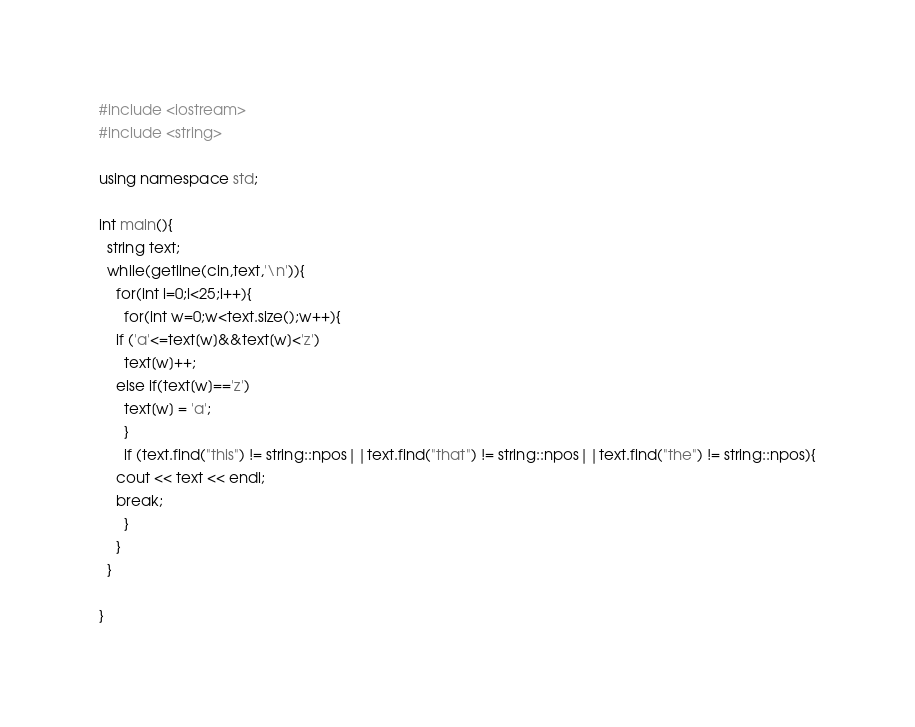Convert code to text. <code><loc_0><loc_0><loc_500><loc_500><_C++_>#include <iostream>
#include <string>

using namespace std;

int main(){
  string text;
  while(getline(cin,text,'\n')){
    for(int i=0;i<25;i++){
      for(int w=0;w<text.size();w++){
	if ('a'<=text[w]&&text[w]<'z')
	  text[w]++;
	else if(text[w]=='z')
	  text[w] = 'a';
      }
      if (text.find("this") != string::npos||text.find("that") != string::npos||text.find("the") != string::npos){
	cout << text << endl;
	break;
      }
    }
  }
  
}</code> 